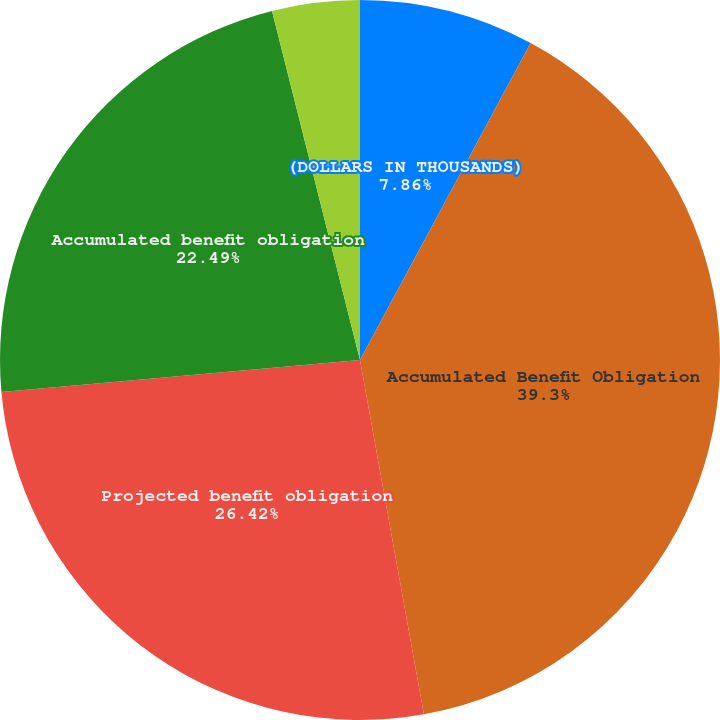<chart> <loc_0><loc_0><loc_500><loc_500><pie_chart><fcel>(DOLLARS IN THOUSANDS)<fcel>Accumulated Benefit Obligation<fcel>Projected benefit obligation<fcel>Accumulated benefit obligation<fcel>Discount rate<fcel>Rate of compensation increase<nl><fcel>7.86%<fcel>39.3%<fcel>26.42%<fcel>22.49%<fcel>3.93%<fcel>0.0%<nl></chart> 